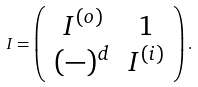<formula> <loc_0><loc_0><loc_500><loc_500>I = \left ( \begin{array} { c c } I ^ { ( o ) } & 1 \\ ( - ) ^ { d } & I ^ { ( i ) } \end{array} \right ) .</formula> 